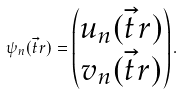<formula> <loc_0><loc_0><loc_500><loc_500>\psi _ { n } ( \vec { t } { r } ) = \begin{pmatrix} u _ { n } ( \vec { t } { r } ) \\ v _ { n } ( \vec { t } { r } ) \end{pmatrix} .</formula> 